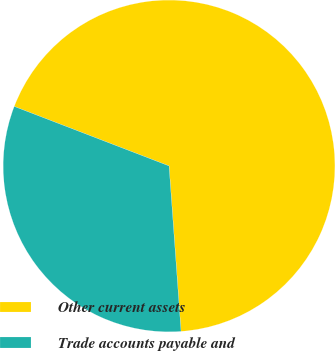<chart> <loc_0><loc_0><loc_500><loc_500><pie_chart><fcel>Other current assets<fcel>Trade accounts payable and<nl><fcel>68.01%<fcel>31.99%<nl></chart> 